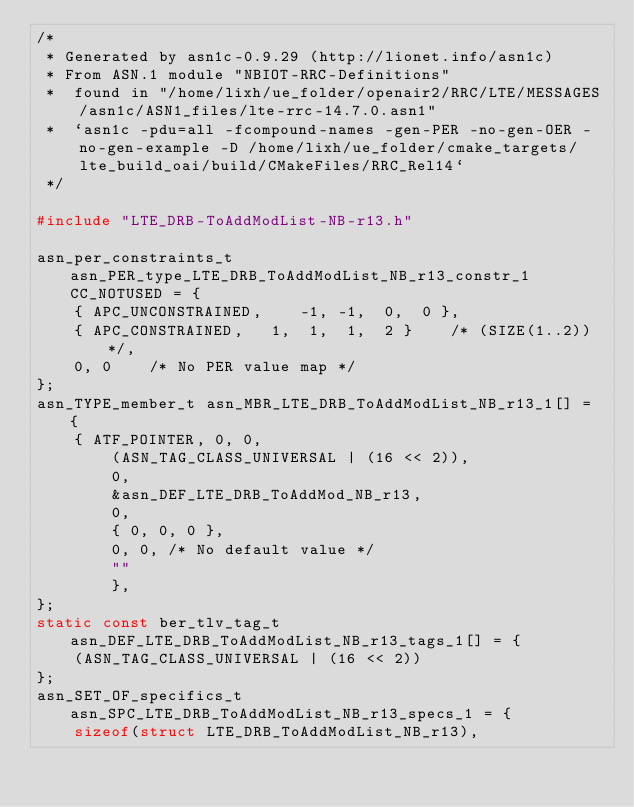<code> <loc_0><loc_0><loc_500><loc_500><_C_>/*
 * Generated by asn1c-0.9.29 (http://lionet.info/asn1c)
 * From ASN.1 module "NBIOT-RRC-Definitions"
 * 	found in "/home/lixh/ue_folder/openair2/RRC/LTE/MESSAGES/asn1c/ASN1_files/lte-rrc-14.7.0.asn1"
 * 	`asn1c -pdu=all -fcompound-names -gen-PER -no-gen-OER -no-gen-example -D /home/lixh/ue_folder/cmake_targets/lte_build_oai/build/CMakeFiles/RRC_Rel14`
 */

#include "LTE_DRB-ToAddModList-NB-r13.h"

asn_per_constraints_t asn_PER_type_LTE_DRB_ToAddModList_NB_r13_constr_1 CC_NOTUSED = {
	{ APC_UNCONSTRAINED,	-1, -1,  0,  0 },
	{ APC_CONSTRAINED,	 1,  1,  1,  2 }	/* (SIZE(1..2)) */,
	0, 0	/* No PER value map */
};
asn_TYPE_member_t asn_MBR_LTE_DRB_ToAddModList_NB_r13_1[] = {
	{ ATF_POINTER, 0, 0,
		(ASN_TAG_CLASS_UNIVERSAL | (16 << 2)),
		0,
		&asn_DEF_LTE_DRB_ToAddMod_NB_r13,
		0,
		{ 0, 0, 0 },
		0, 0, /* No default value */
		""
		},
};
static const ber_tlv_tag_t asn_DEF_LTE_DRB_ToAddModList_NB_r13_tags_1[] = {
	(ASN_TAG_CLASS_UNIVERSAL | (16 << 2))
};
asn_SET_OF_specifics_t asn_SPC_LTE_DRB_ToAddModList_NB_r13_specs_1 = {
	sizeof(struct LTE_DRB_ToAddModList_NB_r13),</code> 